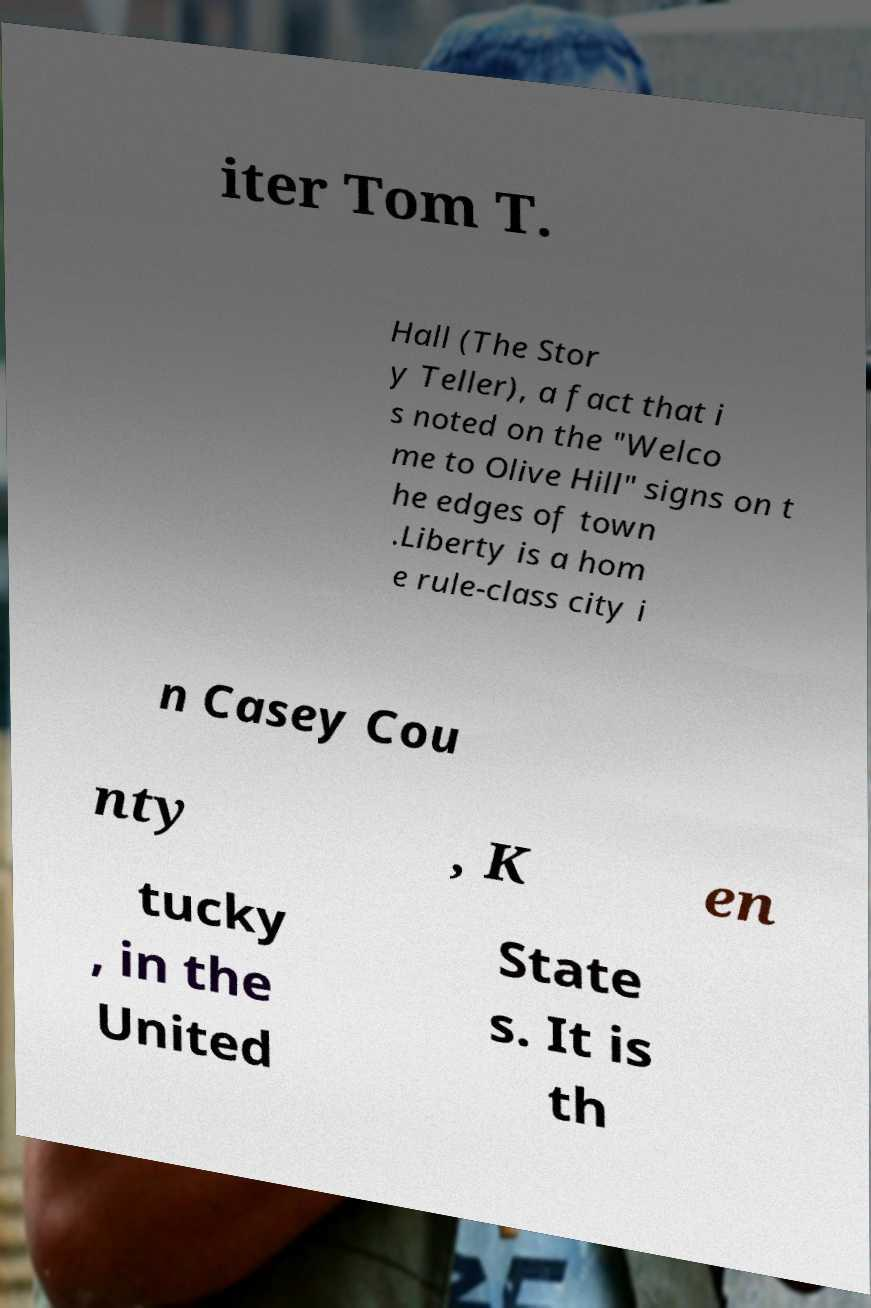Could you assist in decoding the text presented in this image and type it out clearly? iter Tom T. Hall (The Stor y Teller), a fact that i s noted on the "Welco me to Olive Hill" signs on t he edges of town .Liberty is a hom e rule-class city i n Casey Cou nty , K en tucky , in the United State s. It is th 